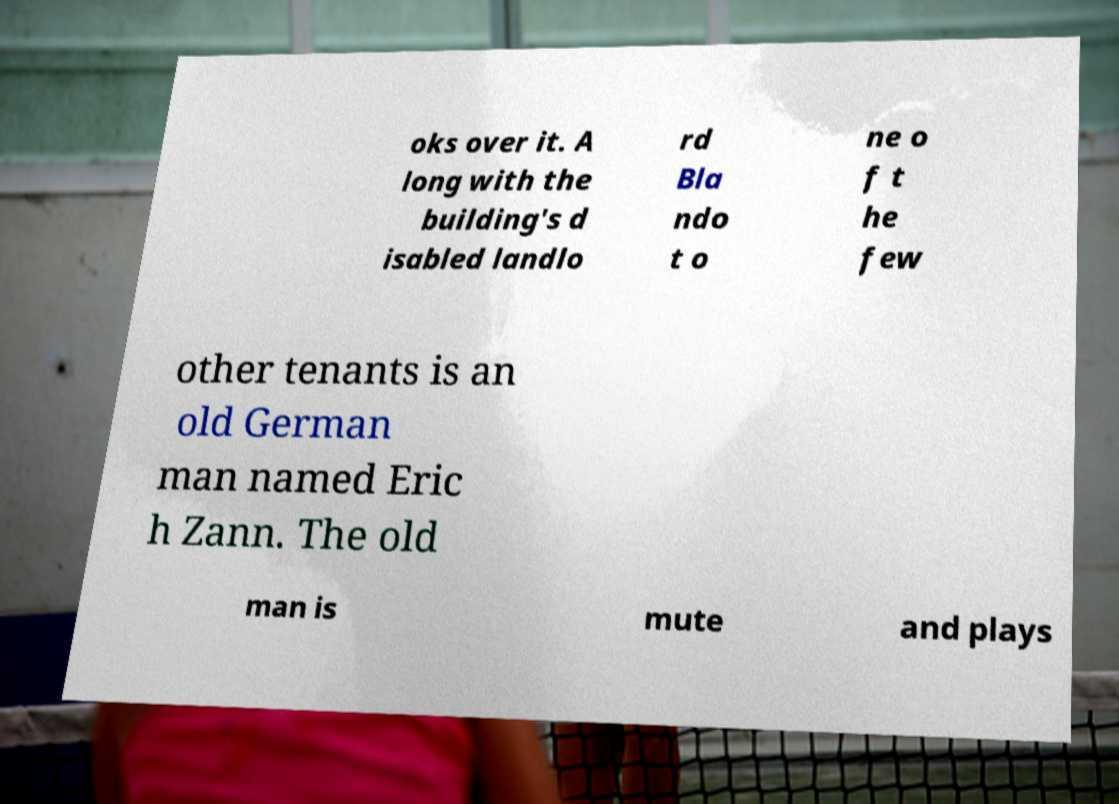What messages or text are displayed in this image? I need them in a readable, typed format. oks over it. A long with the building's d isabled landlo rd Bla ndo t o ne o f t he few other tenants is an old German man named Eric h Zann. The old man is mute and plays 